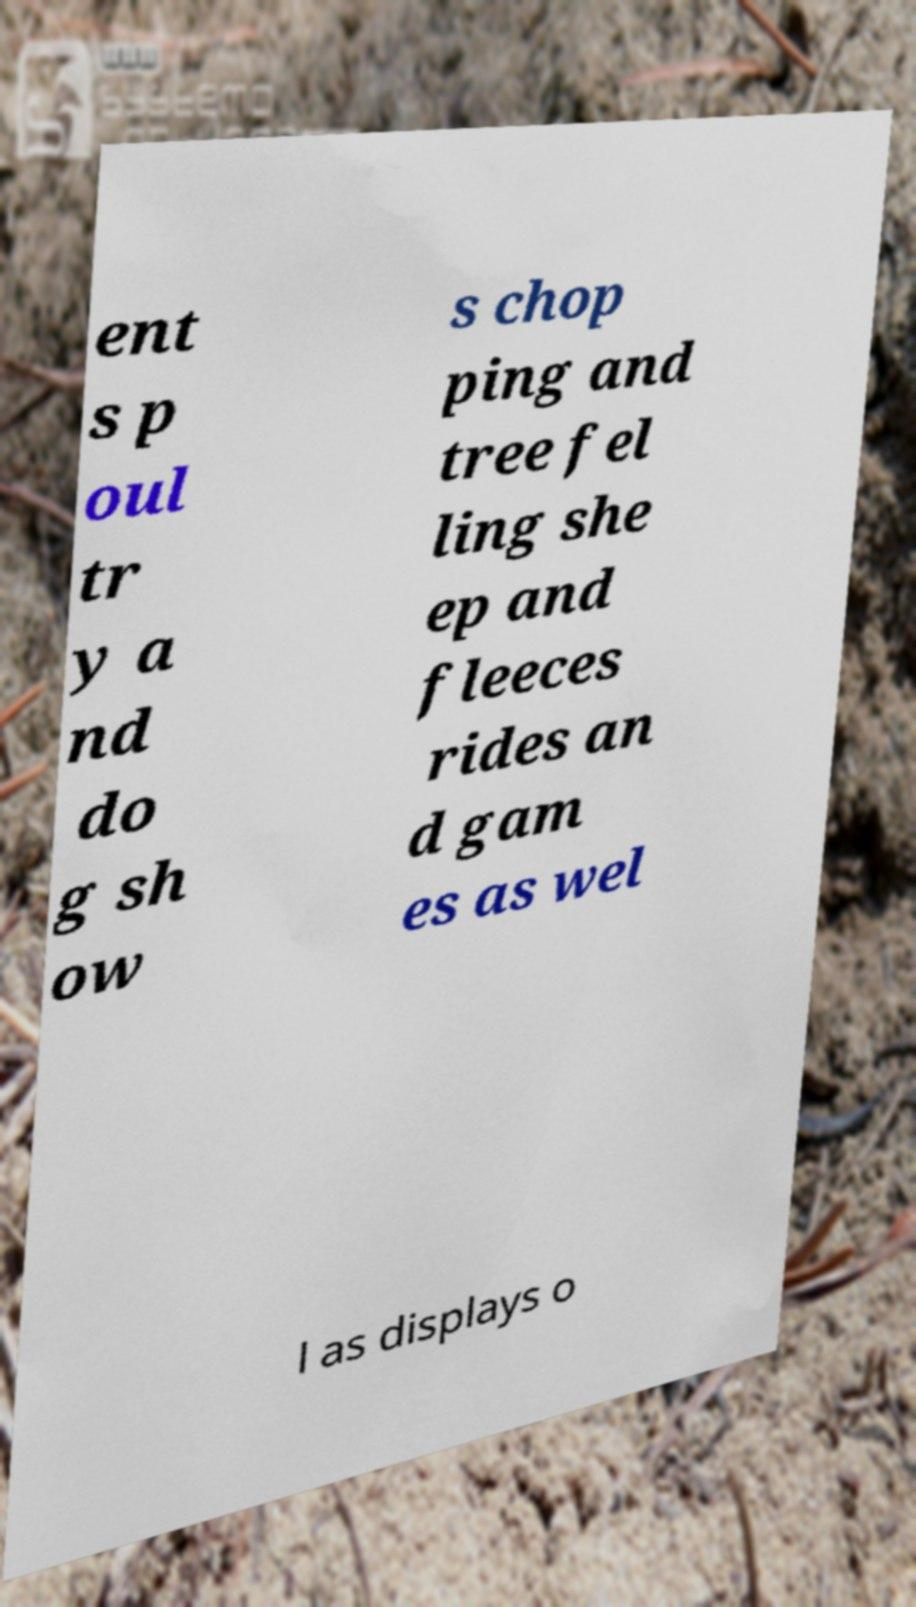Can you accurately transcribe the text from the provided image for me? ent s p oul tr y a nd do g sh ow s chop ping and tree fel ling she ep and fleeces rides an d gam es as wel l as displays o 